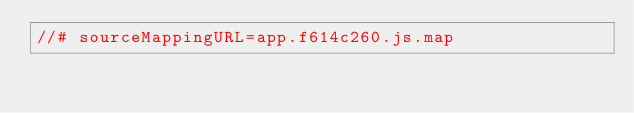<code> <loc_0><loc_0><loc_500><loc_500><_JavaScript_>//# sourceMappingURL=app.f614c260.js.map
</code> 